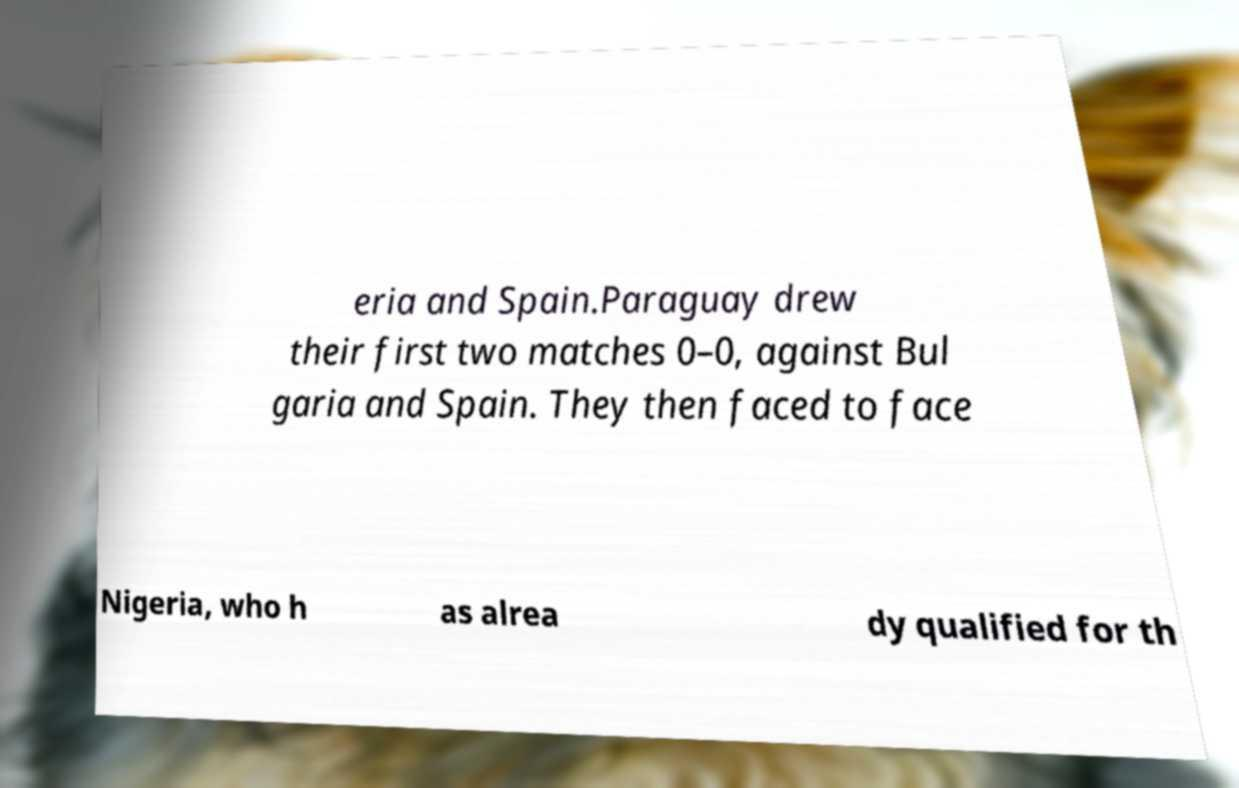What messages or text are displayed in this image? I need them in a readable, typed format. eria and Spain.Paraguay drew their first two matches 0–0, against Bul garia and Spain. They then faced to face Nigeria, who h as alrea dy qualified for th 